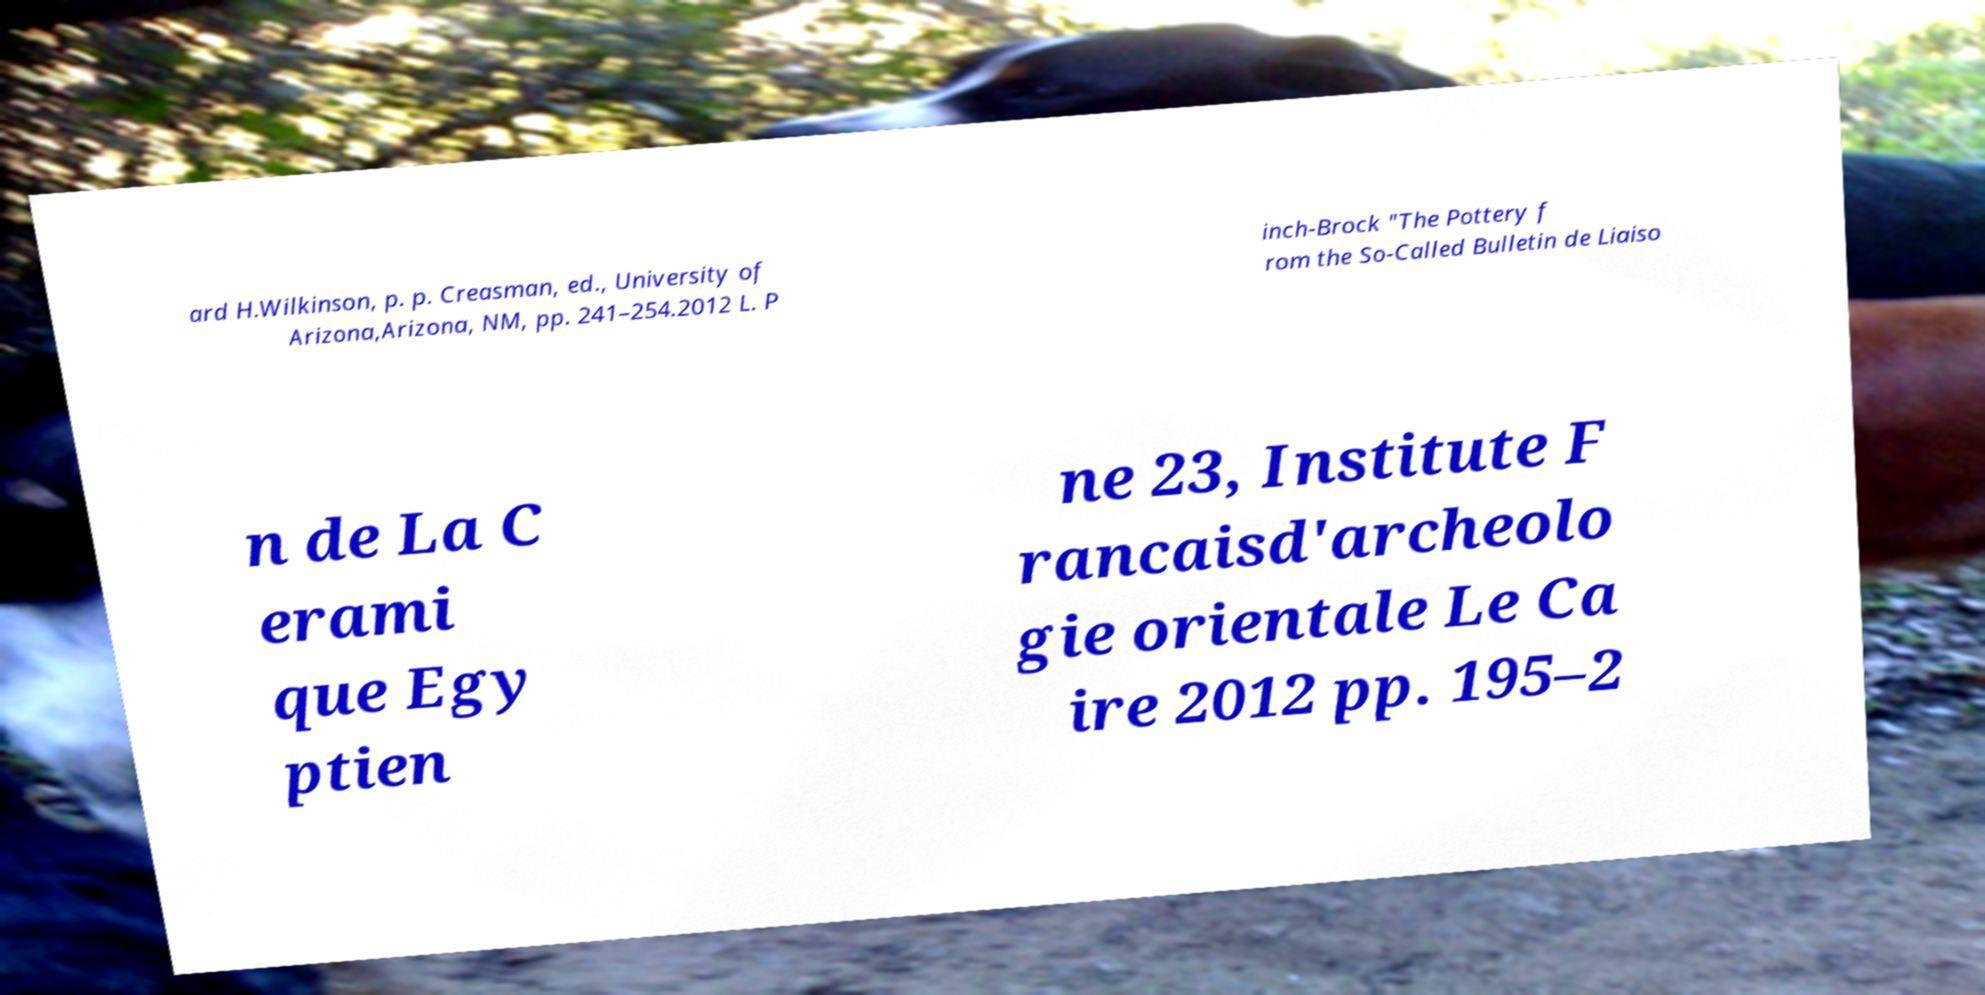What messages or text are displayed in this image? I need them in a readable, typed format. ard H.Wilkinson, p. p. Creasman, ed., University of Arizona,Arizona, NM, pp. 241–254.2012 L. P inch-Brock "The Pottery f rom the So-Called Bulletin de Liaiso n de La C erami que Egy ptien ne 23, Institute F rancaisd'archeolo gie orientale Le Ca ire 2012 pp. 195–2 